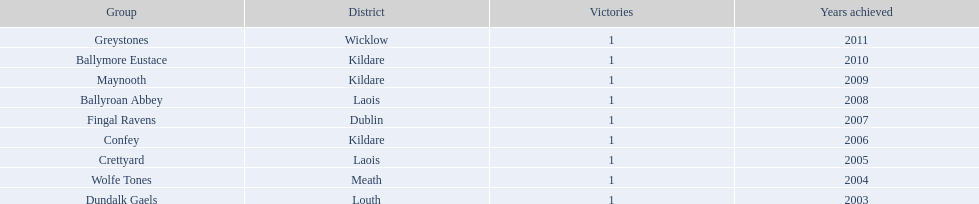What county is the team that won in 2009 from? Kildare. What is the teams name? Maynooth. 